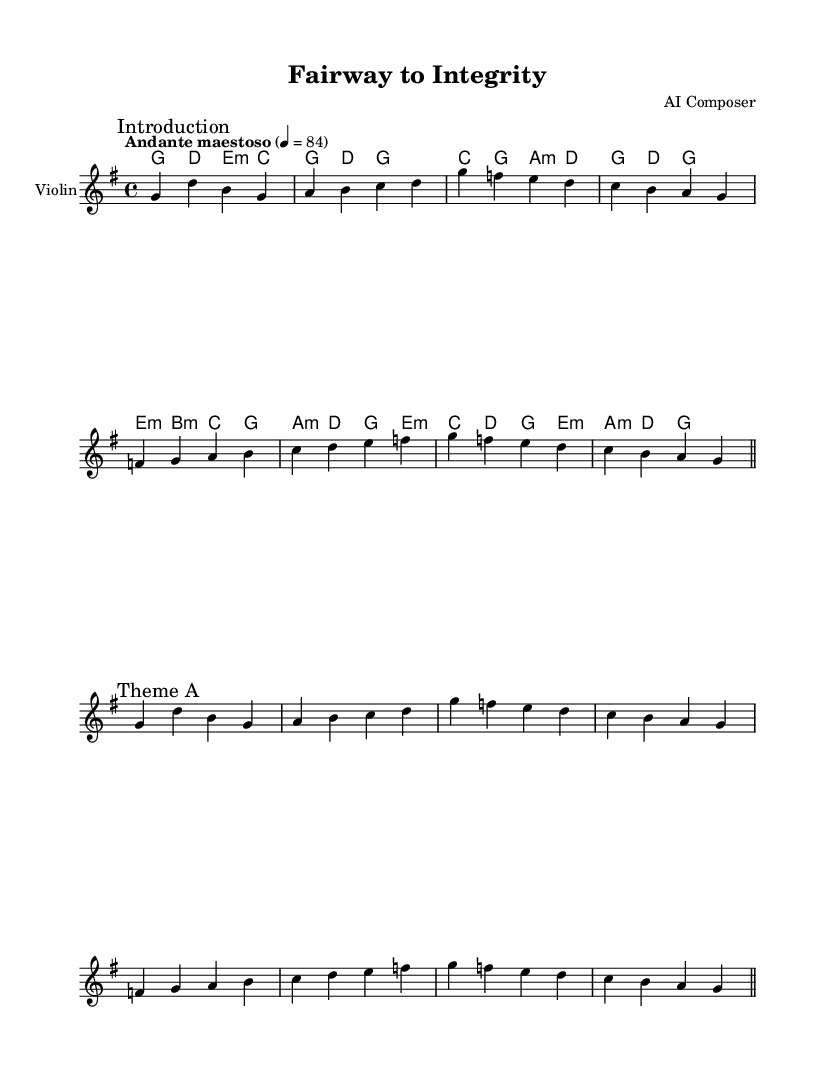What is the key signature of this music? The key signature is G major, indicated by one sharp (F#) in the music.
Answer: G major What is the time signature of the piece? The time signature is 4/4, which shows that there are four beats per measure.
Answer: 4/4 What is the tempo marking for this composition? The tempo marking is "Andante maestoso", indicating a moderately slow pace with dignified character.
Answer: Andante maestoso How many sections are indicated in the piece? The piece contains two main sections: "Introduction" and "Theme A", shown by the markings in the music.
Answer: 2 What is the primary instrument featured in this score? The primary instrument featured in this score is the Violin, as labeled.
Answer: Violin Which chord is played alongside the melody during Theme A? The chord played alongside the melody during Theme A includes G major, which matches the melody notes.
Answer: G major How does the theme reflect personal growth? The theme is built around ascending melodic phrases and harmonies that create a sense of rising action and progression, symbolizing personal growth.
Answer: Rising action 